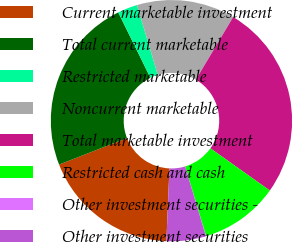Convert chart. <chart><loc_0><loc_0><loc_500><loc_500><pie_chart><fcel>Current marketable investment<fcel>Total current marketable<fcel>Restricted marketable<fcel>Noncurrent marketable<fcel>Total marketable investment<fcel>Restricted cash and cash<fcel>Other investment securities -<fcel>Other investment securities<nl><fcel>18.41%<fcel>23.66%<fcel>2.66%<fcel>13.16%<fcel>26.28%<fcel>10.53%<fcel>0.03%<fcel>5.28%<nl></chart> 